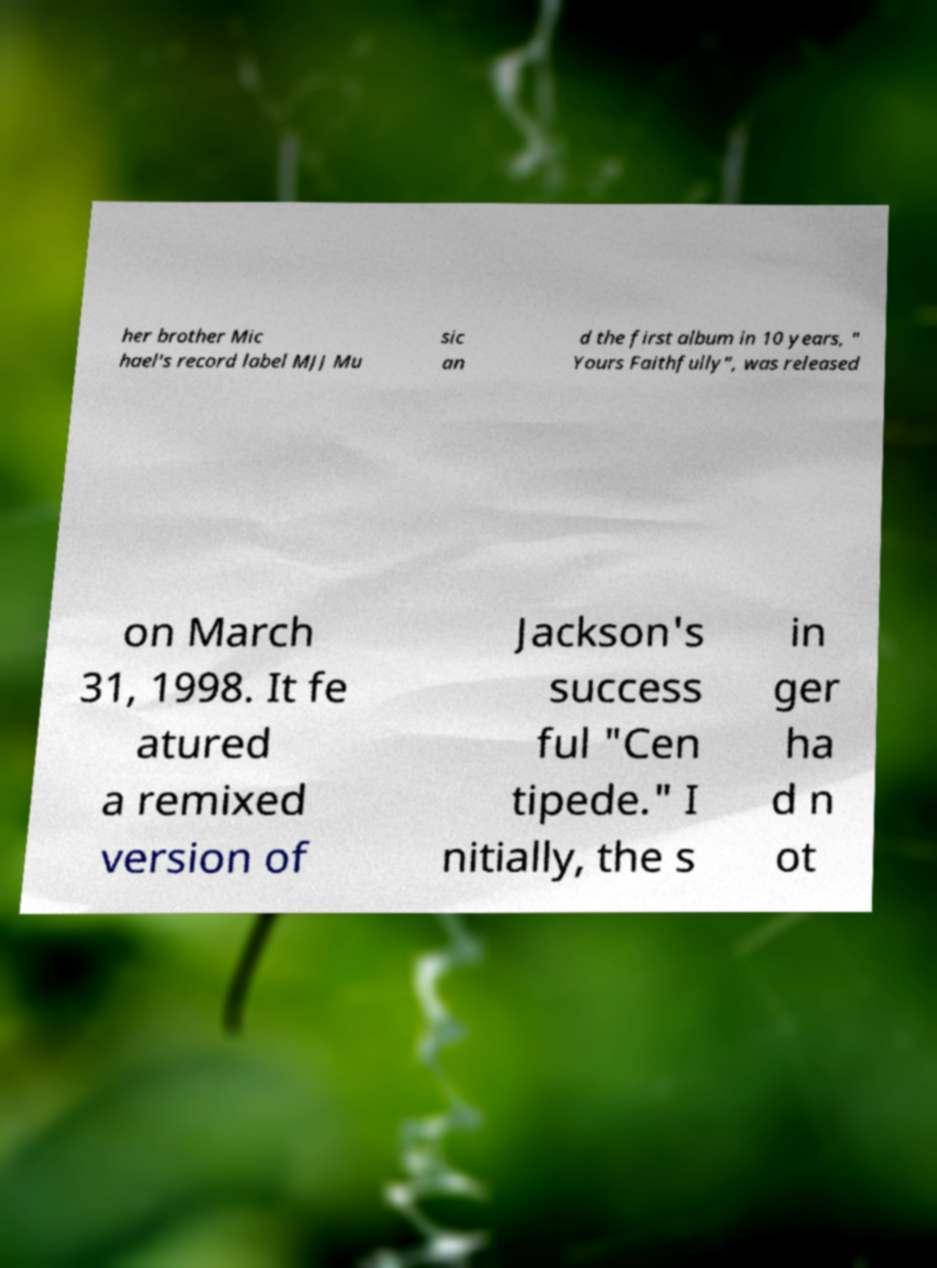Please read and relay the text visible in this image. What does it say? her brother Mic hael's record label MJJ Mu sic an d the first album in 10 years, " Yours Faithfully", was released on March 31, 1998. It fe atured a remixed version of Jackson's success ful "Cen tipede." I nitially, the s in ger ha d n ot 